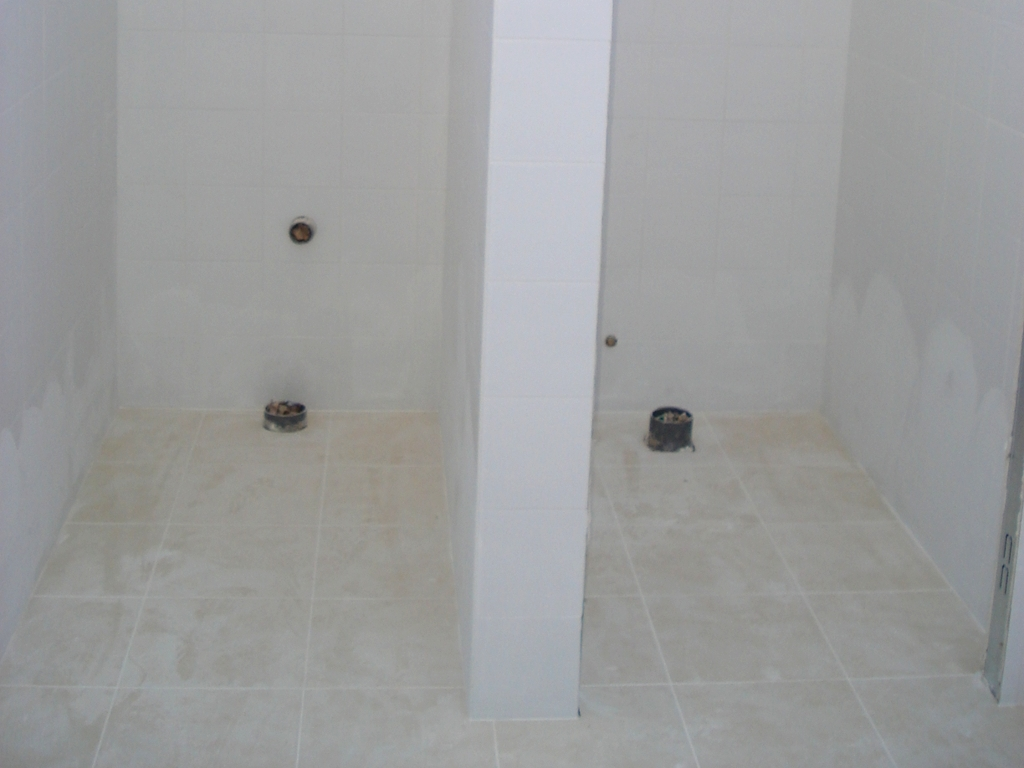How can this space be improved aesthetically? To enhance the aesthetic appeal of this space, one could consider adding design elements that provide visual interest and warmth. This may include artwork or decals on the walls, strategically placing furniture to create an inviting atmosphere, adding texture with rugs or curtains, and incorporating greenery with plants. Ambient lighting and color accents could also be introduced to enliven the space and provide a more engaging visual experience. 